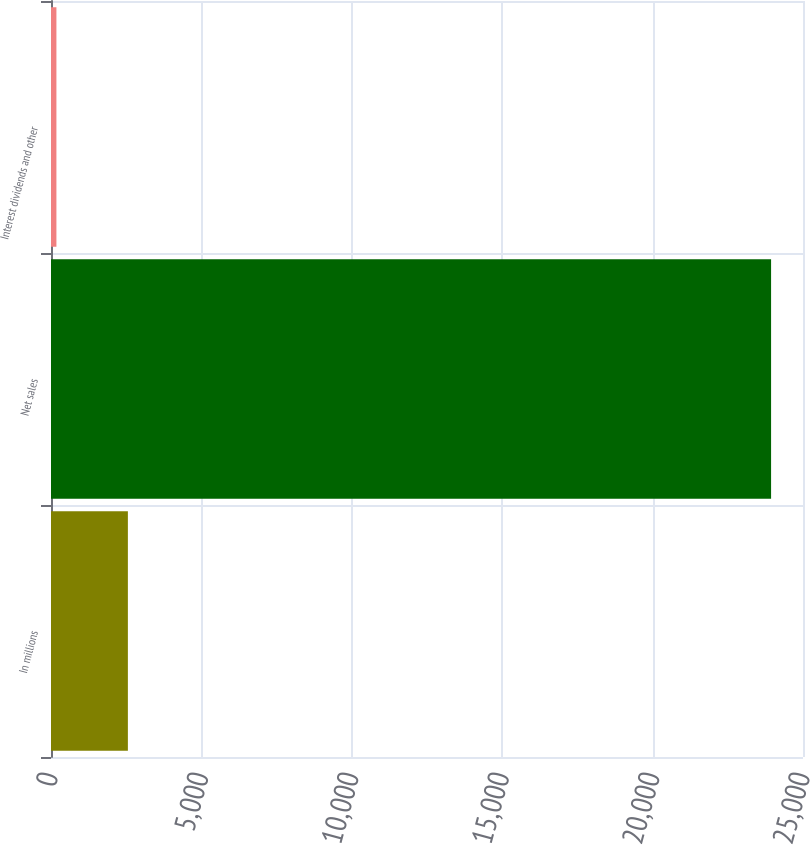<chart> <loc_0><loc_0><loc_500><loc_500><bar_chart><fcel>In millions<fcel>Net sales<fcel>Interest dividends and other<nl><fcel>2555.9<fcel>23939<fcel>180<nl></chart> 